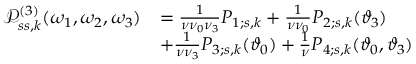Convert formula to latex. <formula><loc_0><loc_0><loc_500><loc_500>\begin{array} { r l } { \mathcal { P } _ { s s , k } ^ { ( 3 ) } ( \omega _ { 1 } , \omega _ { 2 } , \omega _ { 3 } ) } & { = \frac { 1 } { \nu \nu _ { 0 } \nu _ { 3 } } P _ { 1 ; s , k } + \frac { 1 } { \nu \nu _ { 0 } } P _ { 2 ; s , k } ( \vartheta _ { 3 } ) } \\ & { + \frac { 1 } { \nu \nu _ { 3 } } P _ { 3 ; s , k } ( \vartheta _ { 0 } ) + \frac { 1 } { \nu } P _ { 4 ; s , k } ( \vartheta _ { 0 } , \vartheta _ { 3 } ) } \end{array}</formula> 